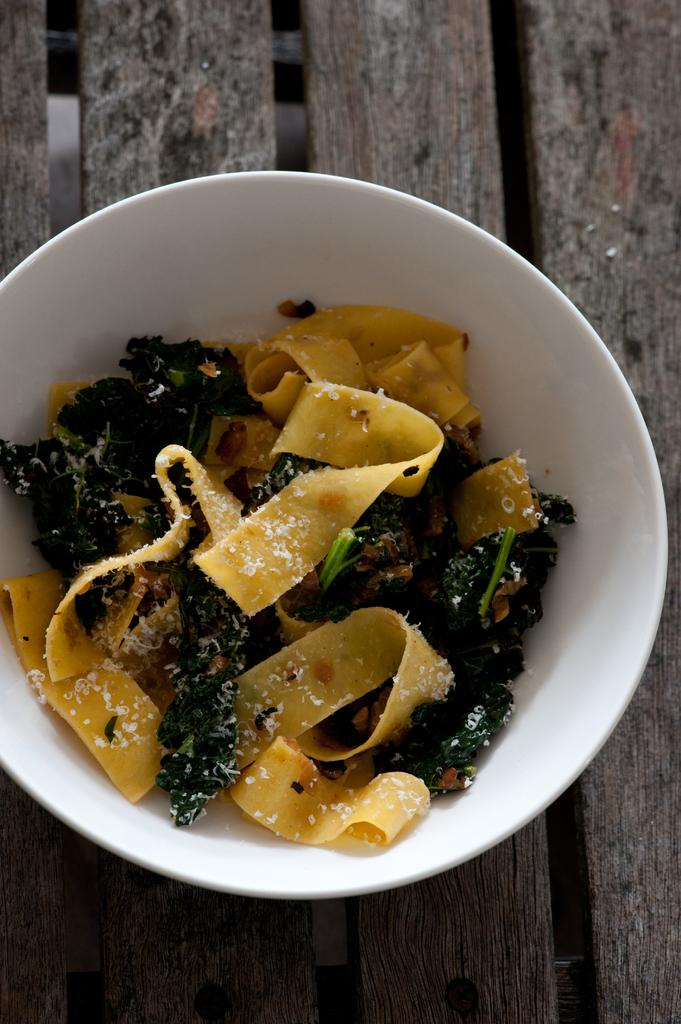What is in the bowl that is visible in the image? There is food in a bowl in the image. Can you hear the music playing in the background of the image? There is no mention of music or any sound in the image, so it cannot be determined if music is playing in the background. 